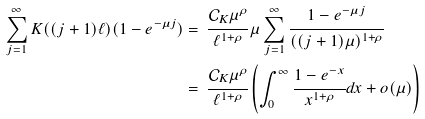<formula> <loc_0><loc_0><loc_500><loc_500>\sum _ { j = 1 } ^ { \infty } K ( ( j + 1 ) \ell ) ( 1 - e ^ { - \mu j } ) & = \, \cfrac { { \mathcal { C } } _ { K } \mu ^ { \rho } } { \ell ^ { 1 + \rho } } \, \mu \sum _ { j = 1 } ^ { \infty } \cfrac { 1 - e ^ { - \mu j } } { ( ( j + 1 ) \mu ) ^ { 1 + \rho } } \\ & = \, \cfrac { { \mathcal { C } } _ { K } \mu ^ { \rho } } { \ell ^ { 1 + \rho } } \left ( \int _ { 0 } ^ { \infty } \cfrac { 1 - e ^ { - x } } { x ^ { 1 + \rho } } d x + o ( \mu ) \right )</formula> 